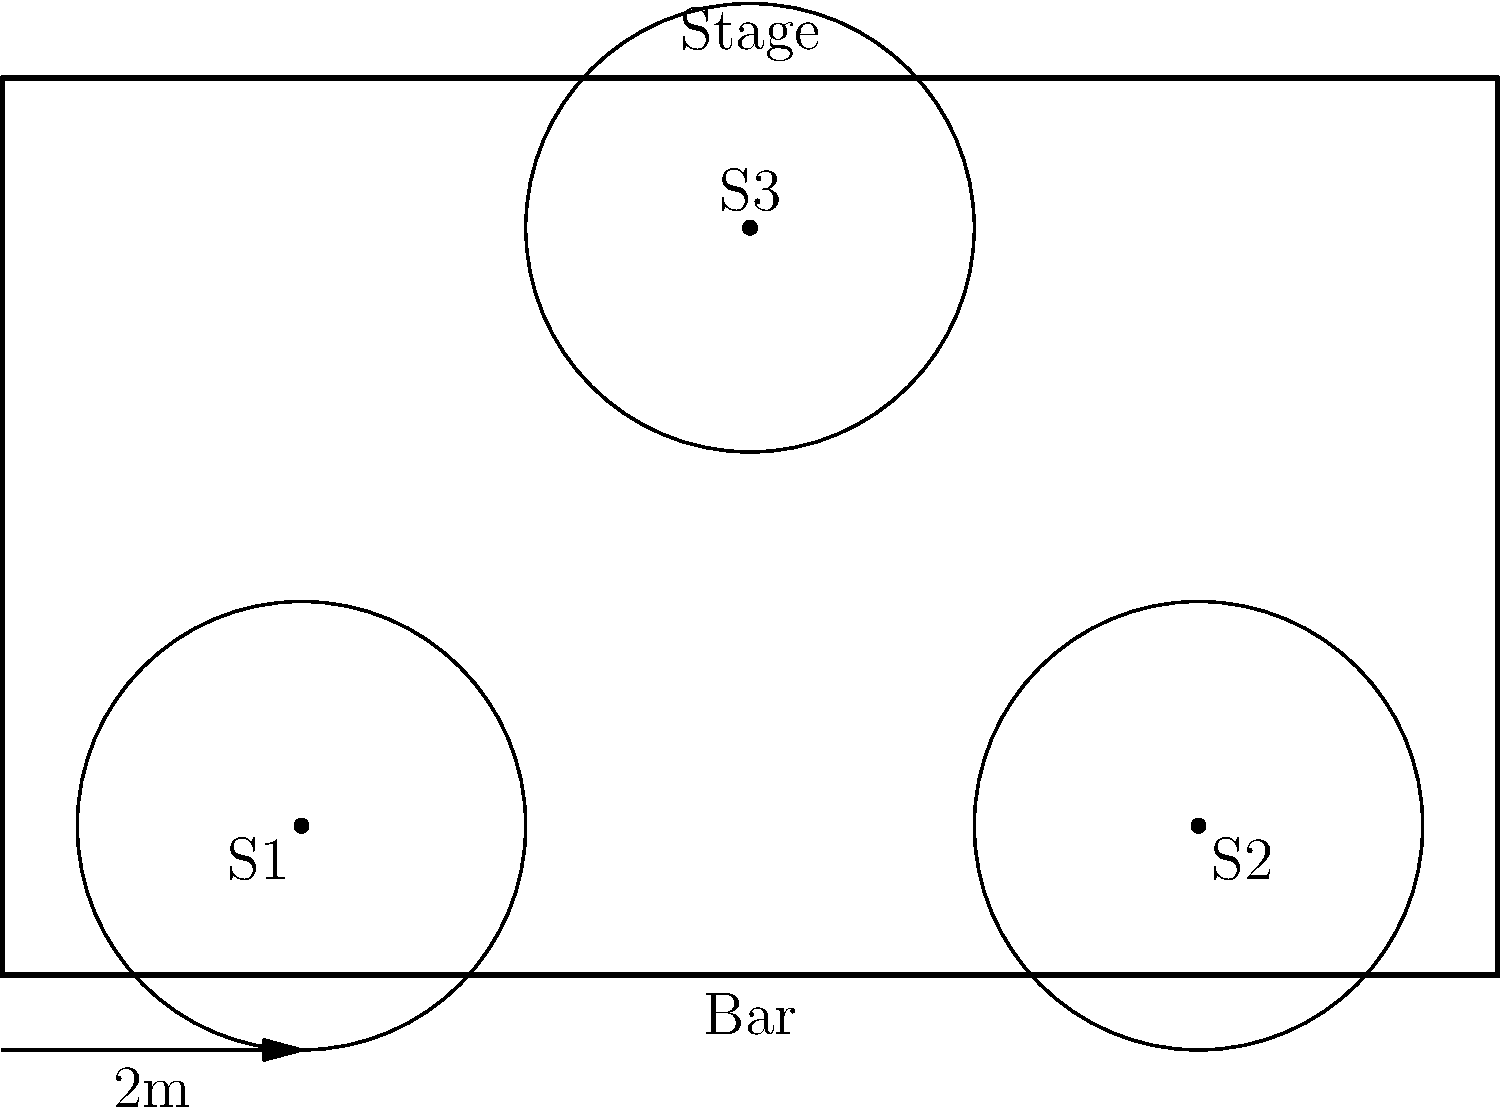In the bar layout shown above, three speakers (S1, S2, and S3) are placed to provide sound coverage. Each speaker has an effective coverage radius of 3 meters. Estimate the percentage of the bar's floor area that is covered by at least one speaker. Round your answer to the nearest 5%. To estimate the coverage area of the speakers, we'll follow these steps:

1. Calculate the total area of the bar:
   Bar dimensions: 10m x 6m
   Total area = $10 \times 6 = 60$ m²

2. Calculate the area covered by each speaker:
   Speaker radius = 3m
   Area per speaker = $\pi r^2 = \pi \times 3^2 \approx 28.27$ m²

3. Estimate the overlapping areas:
   - S1 and S2 have minimal overlap
   - S3 overlaps partially with both S1 and S2

4. Estimate the total coverage area:
   Approximated coverage = $(2.5 \times 28.27) \approx 70.68$ m²
   (We use 2.5 instead of 3 to account for overlaps and edge effects)

5. Calculate the percentage of coverage:
   Percentage = $\frac{\text{Covered area}}{\text{Total area}} \times 100\%$
   $= \frac{70.68}{60} \times 100\% \approx 117.8\%$

6. Since the coverage exceeds 100% due to overlaps and extending beyond the bar's boundaries, we can estimate that nearly the entire bar is covered.

7. Rounding to the nearest 5%: 100%
Answer: 100% 